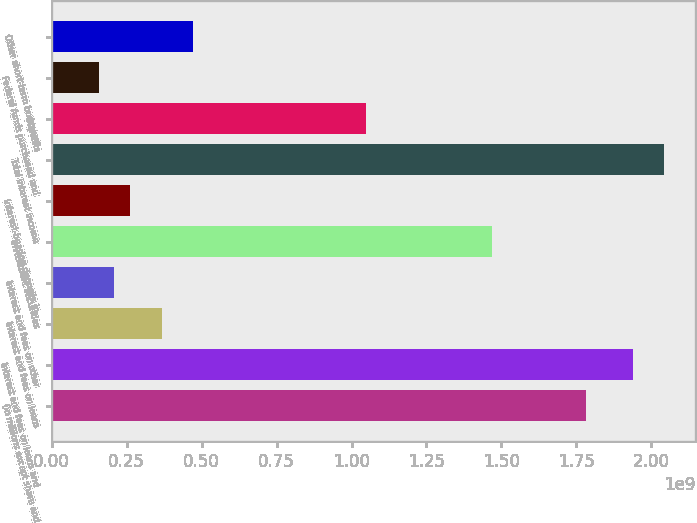Convert chart to OTSL. <chart><loc_0><loc_0><loc_500><loc_500><bar_chart><fcel>(in millions except share and<fcel>Interest and fees on loans and<fcel>Interest and fees on loans<fcel>Interest and fees on other<fcel>Investment securities<fcel>Interest-bearing deposits in<fcel>Total interest income<fcel>Deposits<fcel>Federal funds purchased and<fcel>Other short-term borrowed<nl><fcel>1.78136e+09<fcel>1.93854e+09<fcel>3.66752e+08<fcel>2.09572e+08<fcel>1.46701e+09<fcel>2.61965e+08<fcel>2.04333e+09<fcel>1.04786e+09<fcel>1.57179e+08<fcel>4.71538e+08<nl></chart> 